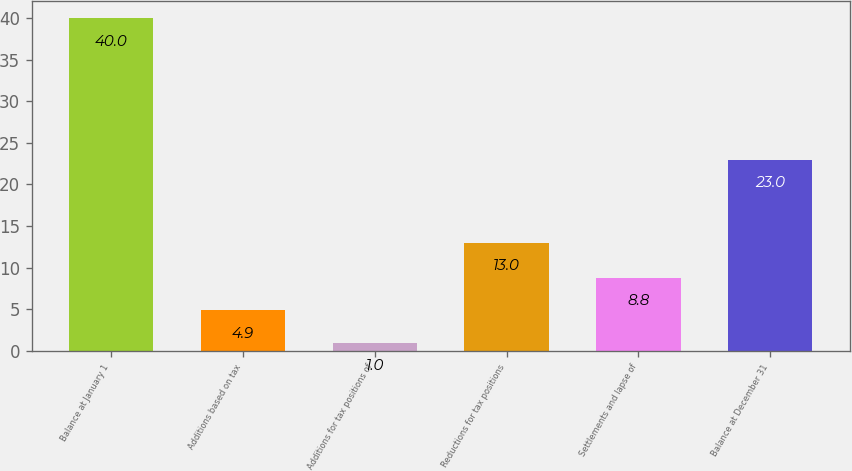Convert chart. <chart><loc_0><loc_0><loc_500><loc_500><bar_chart><fcel>Balance at January 1<fcel>Additions based on tax<fcel>Additions for tax positions of<fcel>Reductions for tax positions<fcel>Settlements and lapse of<fcel>Balance at December 31<nl><fcel>40<fcel>4.9<fcel>1<fcel>13<fcel>8.8<fcel>23<nl></chart> 